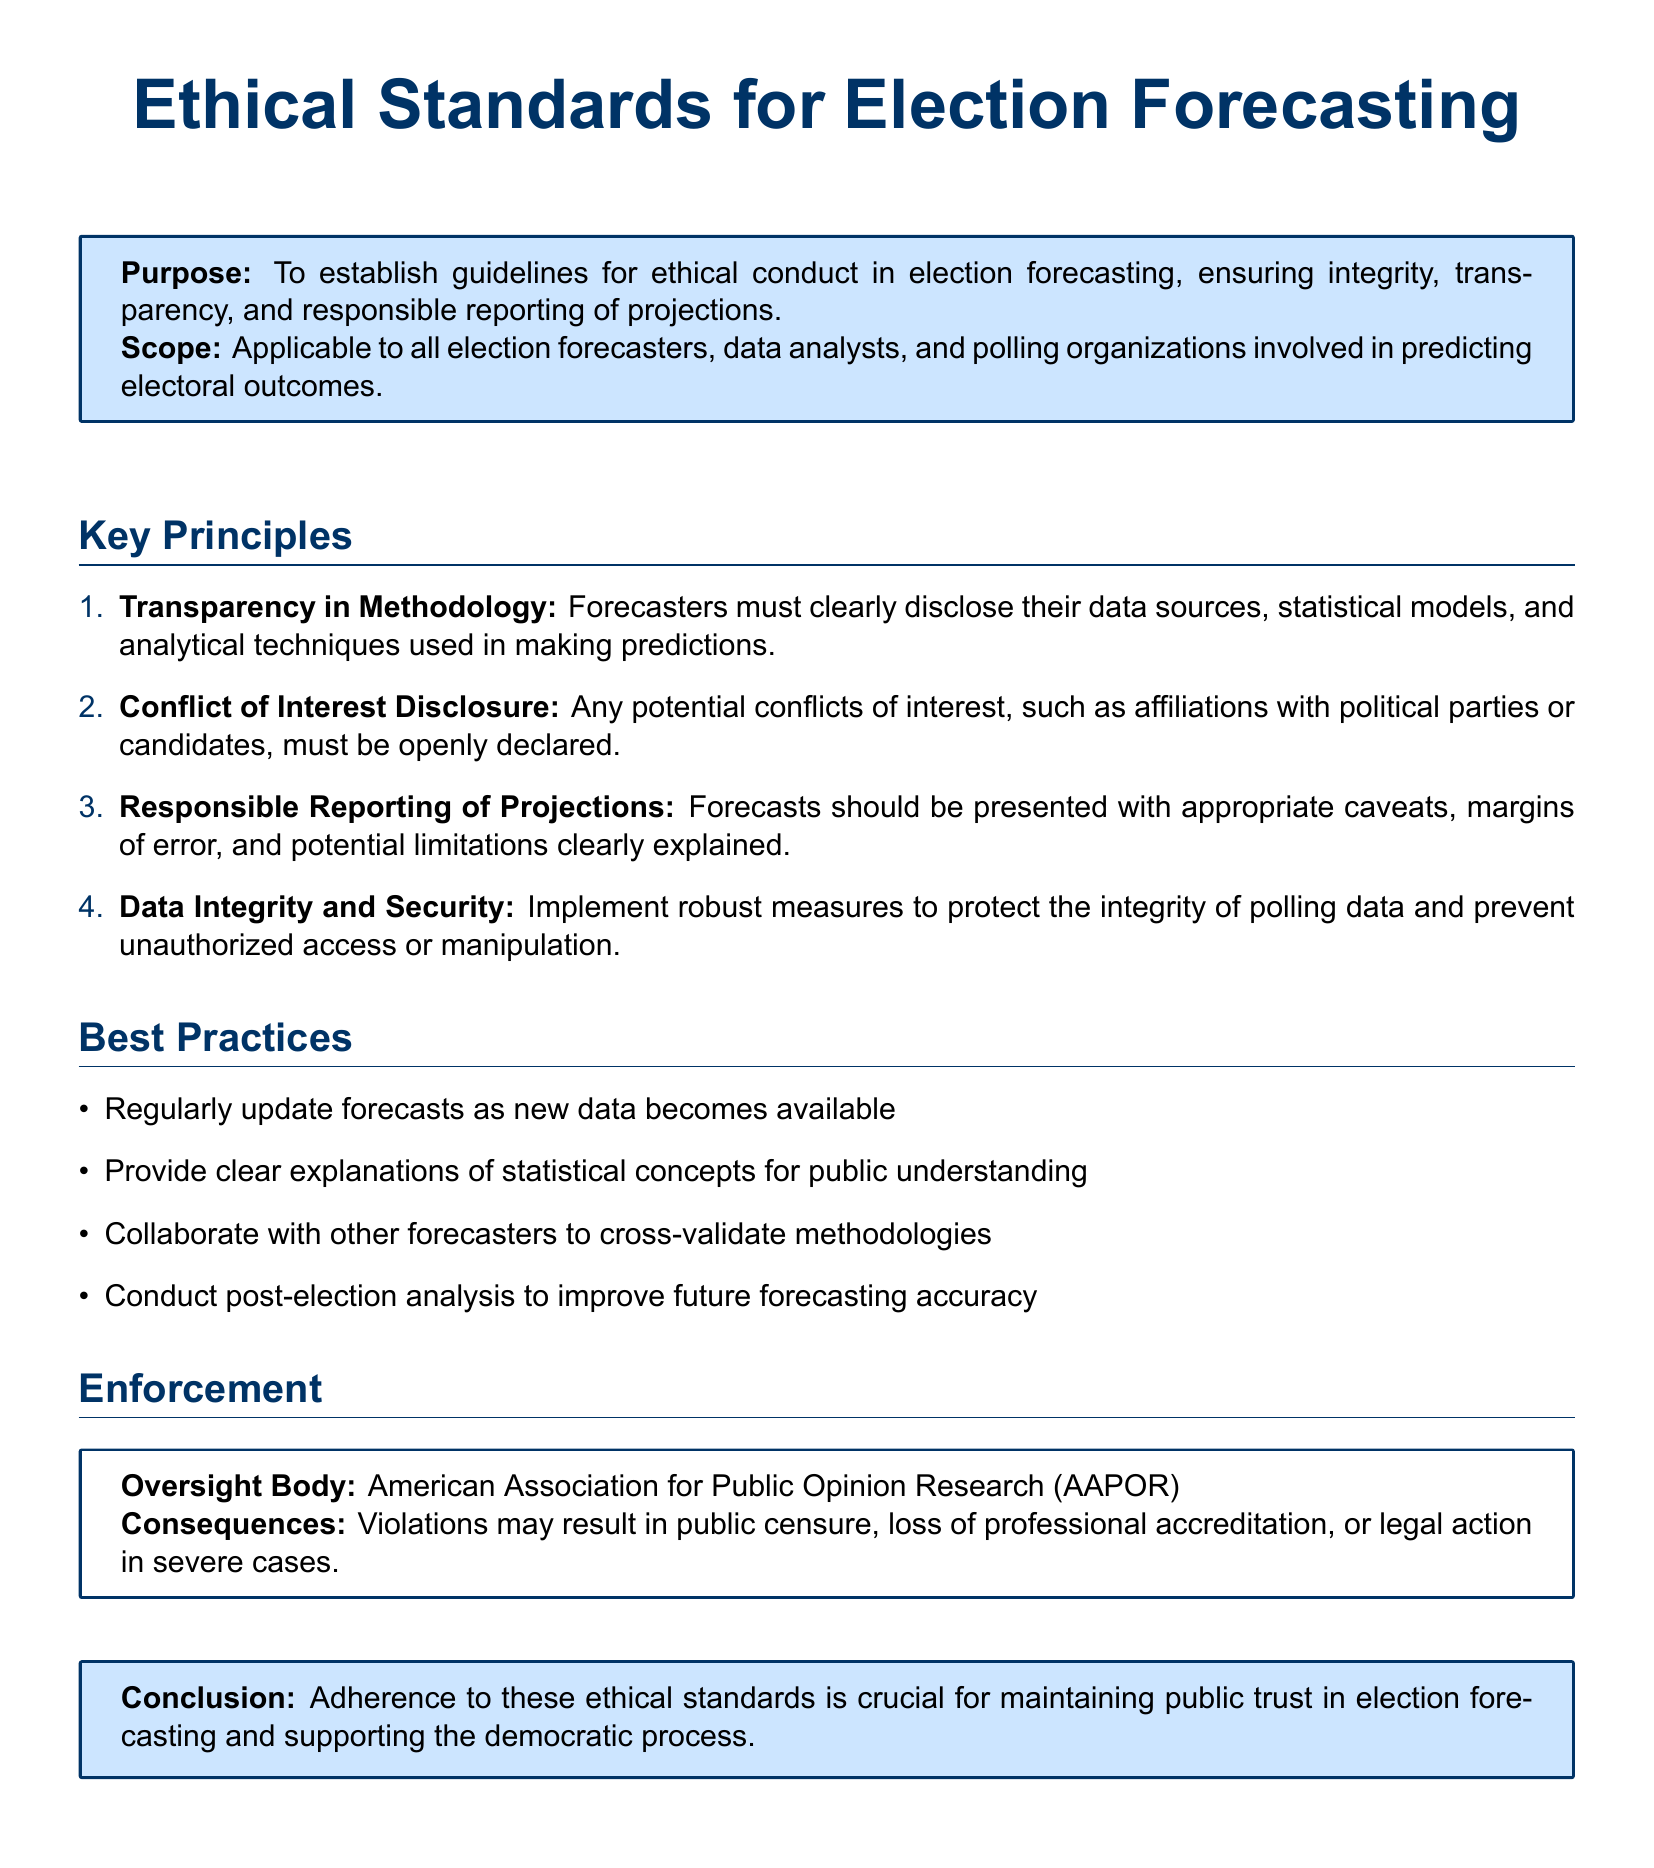What is the purpose of the document? The purpose is to establish guidelines for ethical conduct in election forecasting, ensuring integrity, transparency, and responsible reporting of projections.
Answer: To establish guidelines for ethical conduct in election forecasting Who does the scope of the document apply to? The scope applies to all election forecasters, data analysts, and polling organizations involved in predicting electoral outcomes.
Answer: All election forecasters, data analysts, and polling organizations What is one of the key principles mentioned in the document? One of the key principles is the need for transparency in methodology, which requires forecasters to disclose their data sources, statistical models, and analytical techniques.
Answer: Transparency in Methodology How many best practices are listed in the document? The document lists four best practices to follow for ethical forecasting.
Answer: Four Who oversees the enforcement of these ethical standards? The American Association for Public Opinion Research (AAPOR) is the oversight body for enforcement.
Answer: American Association for Public Opinion Research (AAPOR) What may happen in severe cases of violations? In severe cases, violations may result in legal action.
Answer: Legal action What must be disclosed regarding conflicts of interest? Any potential conflicts of interest, such as affiliations with political parties or candidates, must be openly declared.
Answer: Affiliations with political parties or candidates What is emphasized in the conclusion of the document? The conclusion emphasizes that adherence to ethical standards is crucial for maintaining public trust in election forecasting.
Answer: Maintaining public trust 